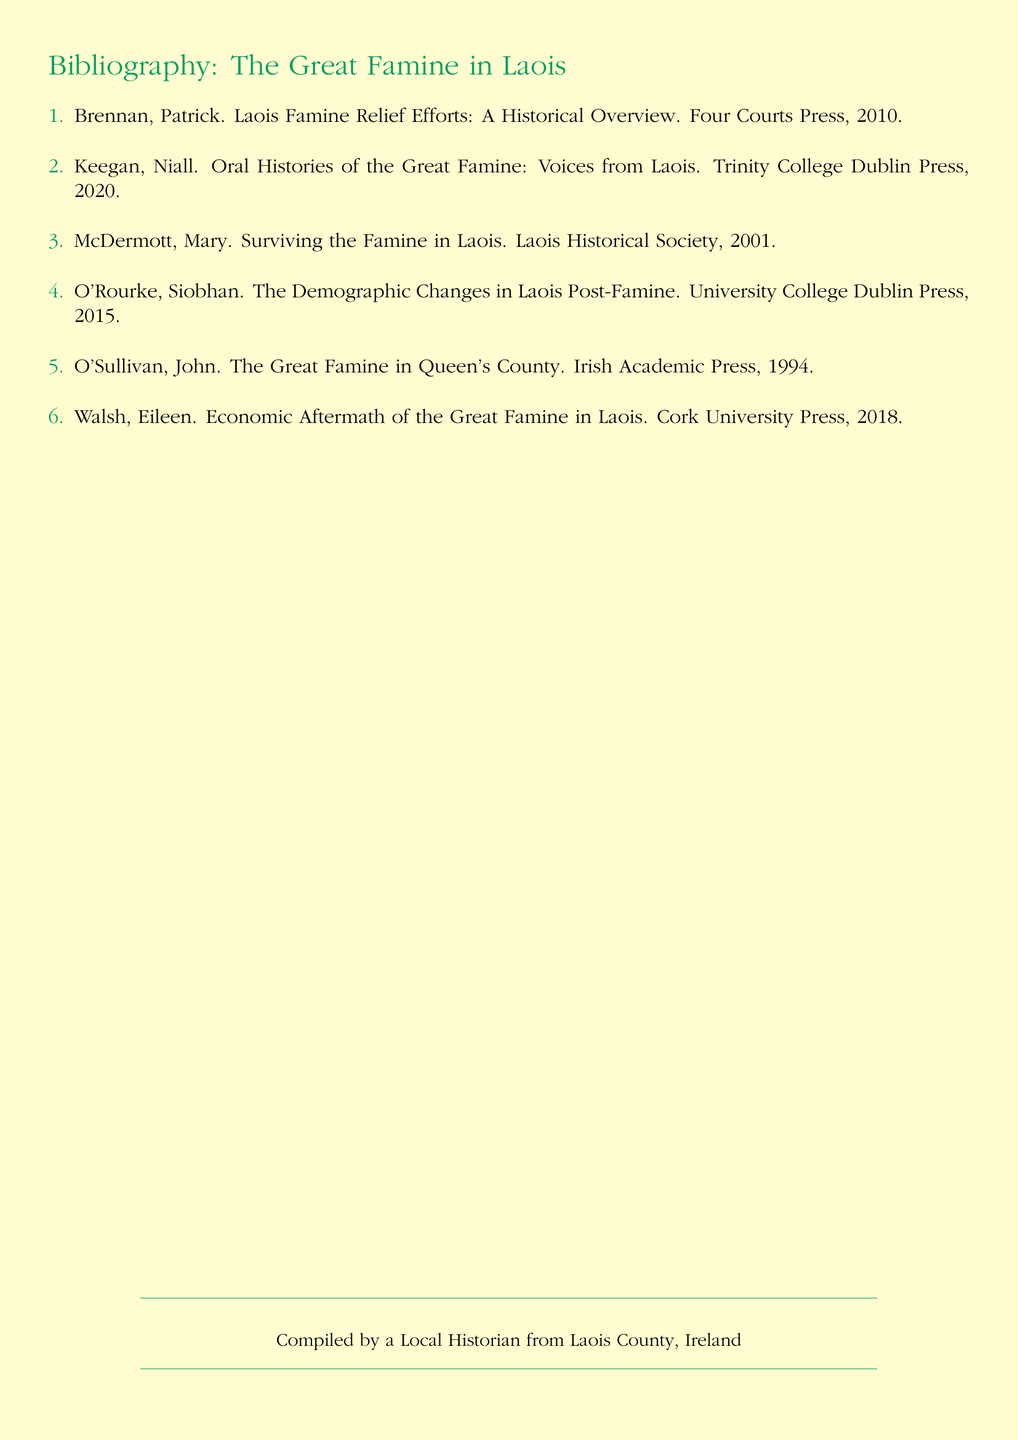What is the title of the first entry? This question asks for the name of the first bibliographic entry listed, which is specifically mentioned in the document.
Answer: Laois Famine Relief Efforts: A Historical Overview Who is the author of the book published in 2018? This question seeks the name of the author from the bibliographic entry published that year, requiring an understanding of publication years.
Answer: Eileen Walsh How many entries are listed in the bibliography? This question asks for the total count of entries provided in the document, which can be easily tallied.
Answer: 6 Which press published the book "Surviving the Famine in Laois"? This question requires the reader to find the publishing press associated with the specific title mentioned in the document.
Answer: Laois Historical Society What year was "The Great Famine in Queen's County" published? This question asks for the publication year of a specific book, requiring retrieval of specific details from the entry.
Answer: 1994 Which entry focuses on oral histories? This question inquires about which specific bibliography entry pertains to oral histories, needing a broad understanding of purpose by title.
Answer: Niall Keegan 